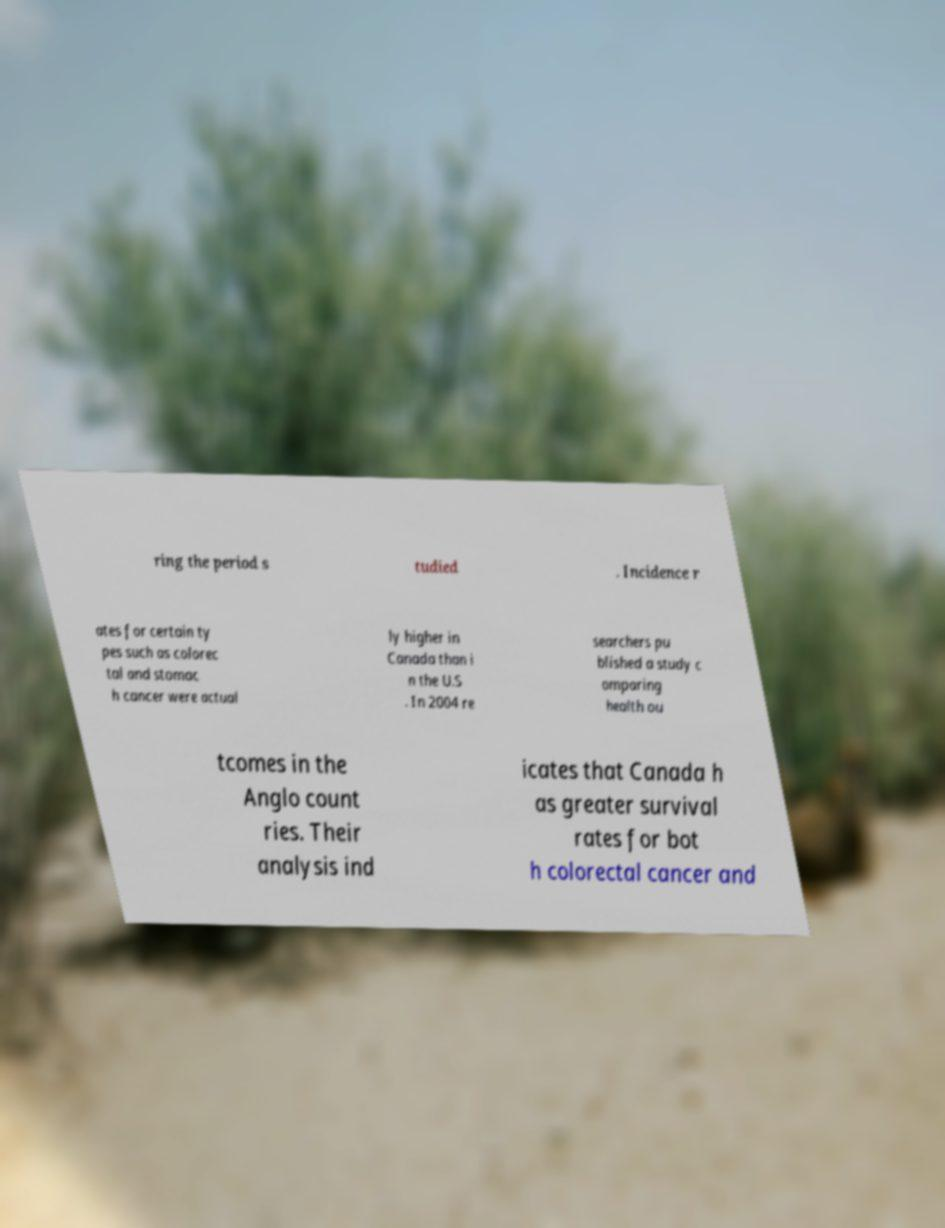For documentation purposes, I need the text within this image transcribed. Could you provide that? ring the period s tudied . Incidence r ates for certain ty pes such as colorec tal and stomac h cancer were actual ly higher in Canada than i n the U.S . In 2004 re searchers pu blished a study c omparing health ou tcomes in the Anglo count ries. Their analysis ind icates that Canada h as greater survival rates for bot h colorectal cancer and 